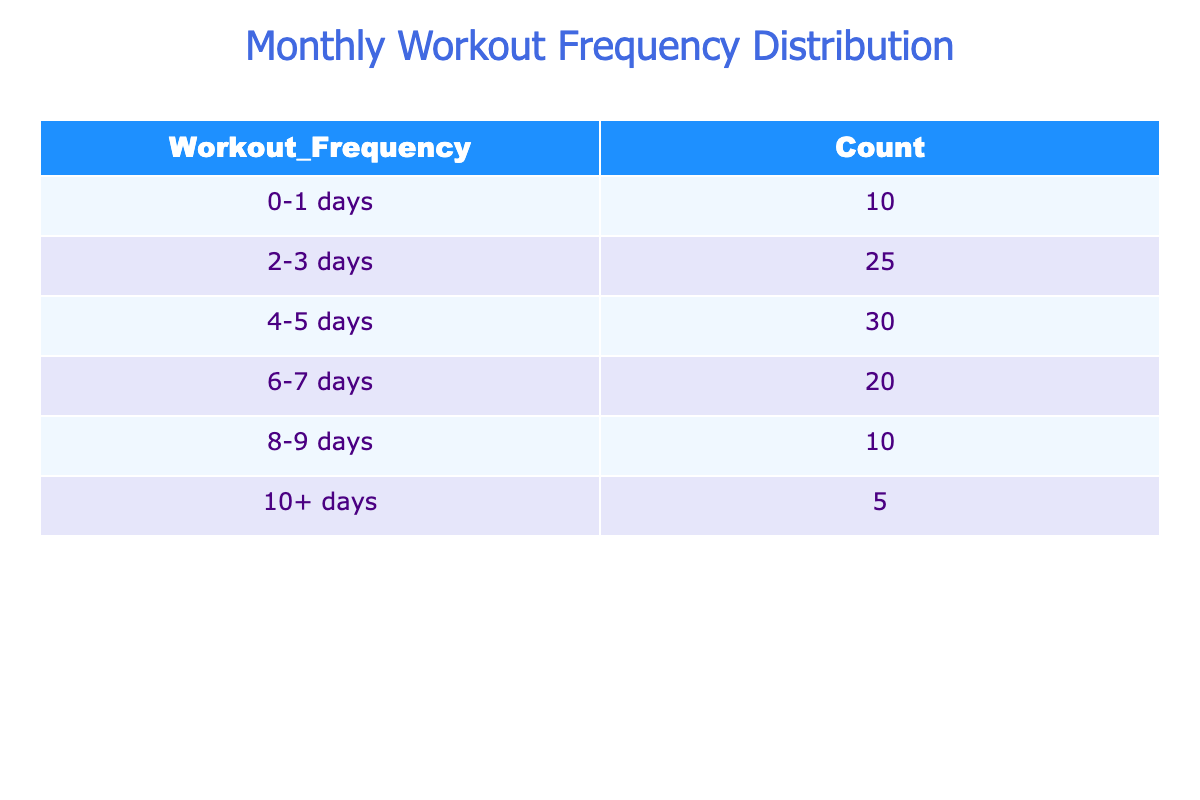What is the count of individuals who worked out 4-5 days? From the table, we can directly refer to the row corresponding to "4-5 days," which shows a count of 30 individuals.
Answer: 30 How many individuals reported working out 0-1 days? The table shows that under the "0-1 days" category, there are 10 individuals.
Answer: 10 What is the total number of individuals who worked out 6 days or more? To find this, we add the counts of "6-7 days" (20) and "10+ days" (5). Therefore, the total is 20 + 5 = 25.
Answer: 25 Is it true that more individuals worked out 2-3 days than 8-9 days? Yes, by comparing the counts, we see that 25 individuals worked out 2-3 days while only 10 worked out 8-9 days.
Answer: Yes What percentage of the total individuals worked out 10 or more days? First, we calculate the total number of individuals: 10 + 25 + 30 + 20 + 10 + 5 = 110. The count for "10+ days" is 5. The percentage is (5 / 110) * 100 = 4.55%.
Answer: 4.55% How does the number of individuals working out 4-5 days compare with those working out 0-1 days? The count of individuals working out 4-5 days is 30, while those working out 0-1 days is 10. The difference is 30 - 10 = 20, indicating significantly more individuals in the 4-5 days category.
Answer: 20 more What is the average workout frequency of individuals who worked out 2-3 days and 4-5 days? We can calculate the average of the workout frequency by taking the midpoints: 2-3 days averages to 2.5 days, and 4-5 days averages to 4.5 days. Therefore, the average is (2.5 + 4.5) / 2 = 3.5 days.
Answer: 3.5 days What is the total count of individuals for all workout frequency categories combined? By summing the counts from each row of the table: 10 + 25 + 30 + 20 + 10 + 5 = 110. Thus, the total count is 110 individuals.
Answer: 110 Which workout frequency category has the highest number of individuals? The highest count is in the "4-5 days" category with 30 individuals, compared to other categories.
Answer: 4-5 days category 